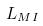Convert formula to latex. <formula><loc_0><loc_0><loc_500><loc_500>L _ { M I }</formula> 